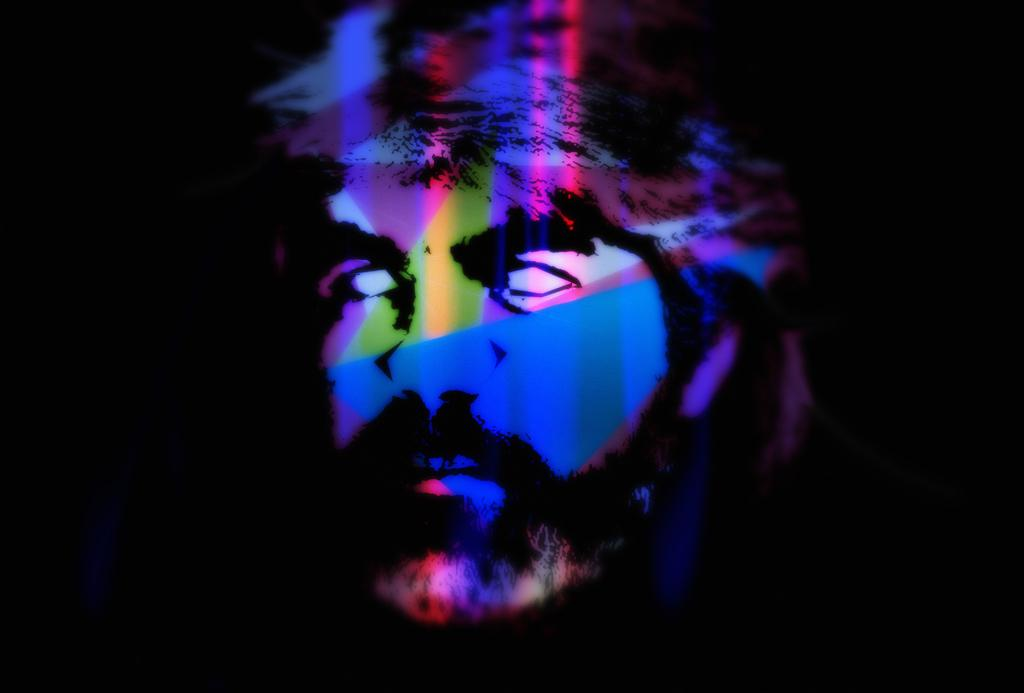What type of image is being described? The image is an animation. How many boats are visible in the crowd in the image? There is no crowd or boats present in the image, as it is an animation and the provided facts do not mention any specific elements or details. 